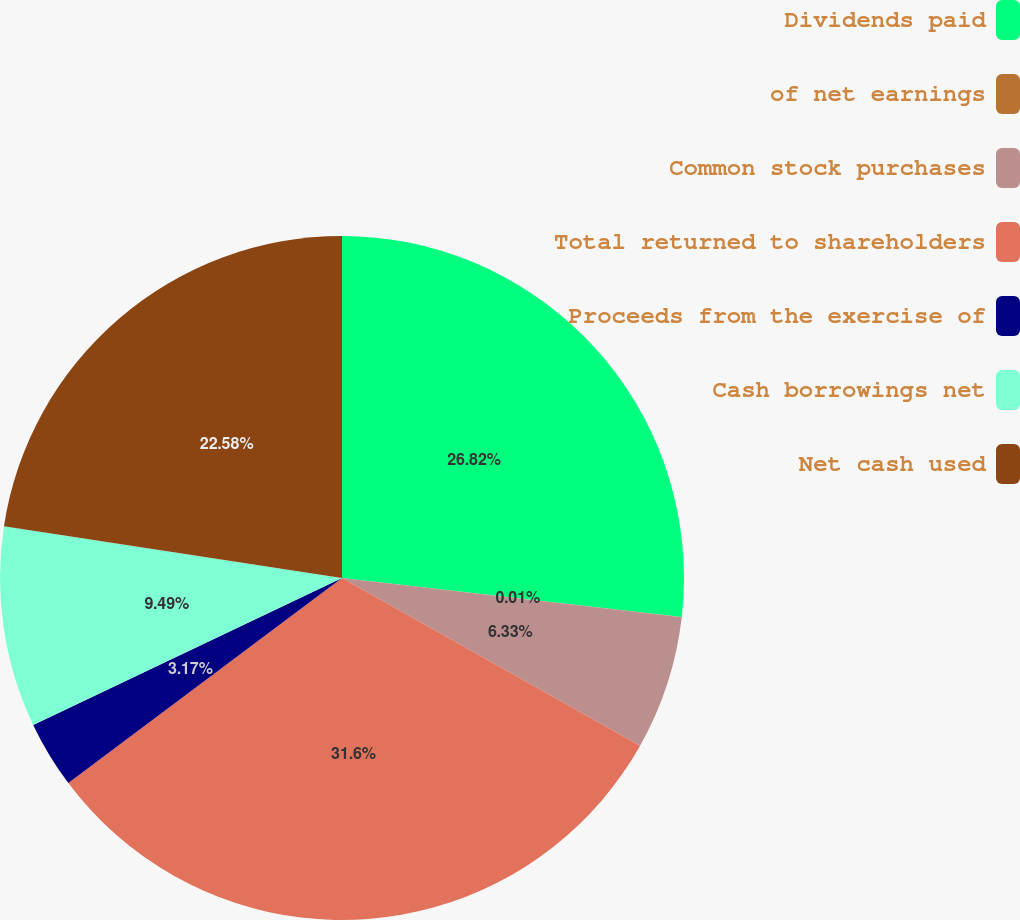Convert chart to OTSL. <chart><loc_0><loc_0><loc_500><loc_500><pie_chart><fcel>Dividends paid<fcel>of net earnings<fcel>Common stock purchases<fcel>Total returned to shareholders<fcel>Proceeds from the exercise of<fcel>Cash borrowings net<fcel>Net cash used<nl><fcel>26.82%<fcel>0.01%<fcel>6.33%<fcel>31.61%<fcel>3.17%<fcel>9.49%<fcel>22.58%<nl></chart> 